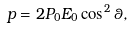Convert formula to latex. <formula><loc_0><loc_0><loc_500><loc_500>p = 2 P _ { 0 } E _ { 0 } \cos ^ { 2 } \theta ,</formula> 